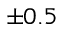<formula> <loc_0><loc_0><loc_500><loc_500>\pm 0 . 5</formula> 